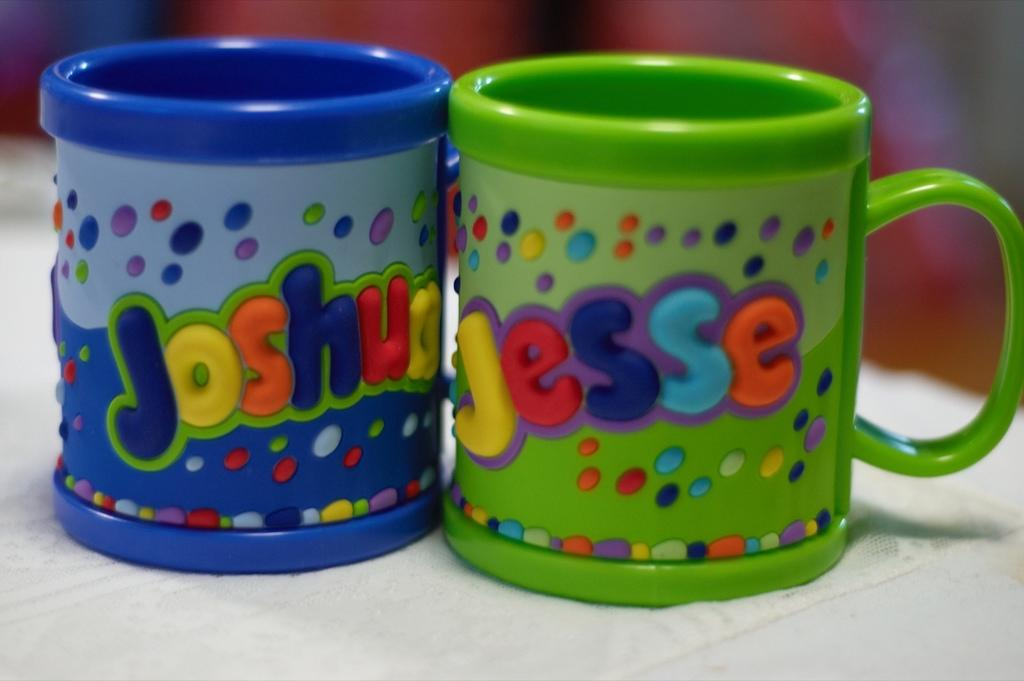Provide a one-sentence caption for the provided image. Two colorful children's mugs with the names Joshua and Jesse. 